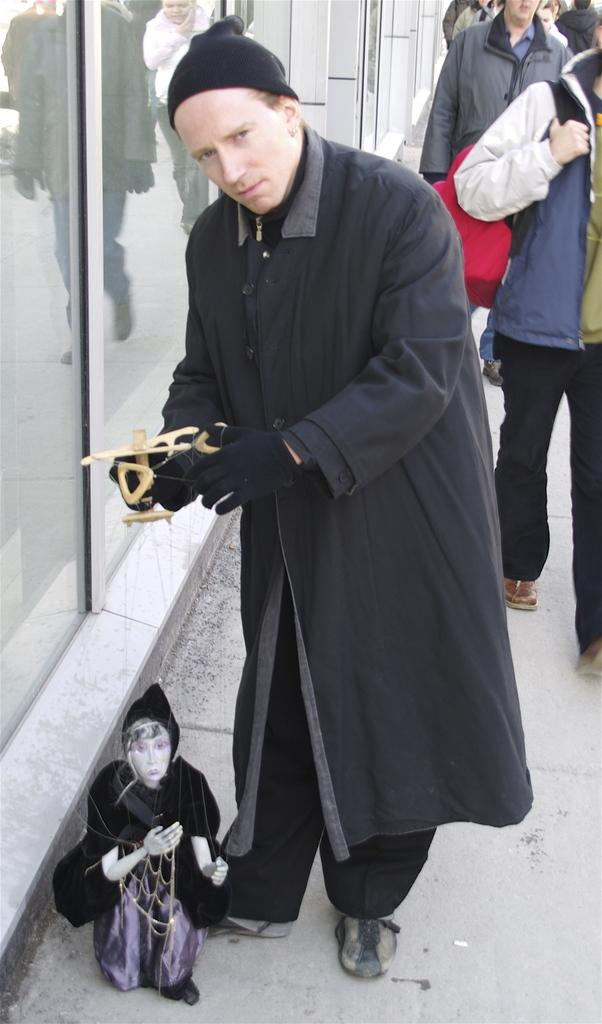How many persons are in the image? There are persons in the image. What are the persons wearing? The persons are wearing clothes. Can you describe the position of the person in the middle? The person in the middle is holding a toy. What is the person in the middle doing with their hand? The person's hand is inside a glass door. Can you tell me what type of juice is being served at the lake in the image? There is no lake or juice present in the image. Is the person in the middle of the image the father of the other persons? The relationship between the persons in the image is not mentioned, so it cannot be determined if the person in the middle is the father of the others. 